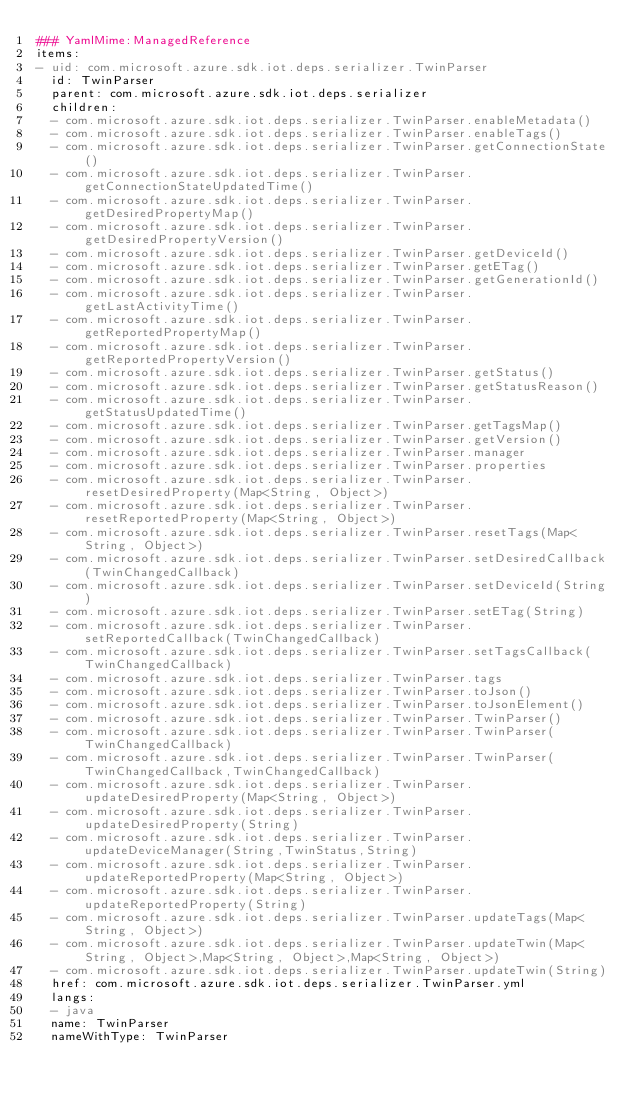<code> <loc_0><loc_0><loc_500><loc_500><_YAML_>### YamlMime:ManagedReference
items:
- uid: com.microsoft.azure.sdk.iot.deps.serializer.TwinParser
  id: TwinParser
  parent: com.microsoft.azure.sdk.iot.deps.serializer
  children:
  - com.microsoft.azure.sdk.iot.deps.serializer.TwinParser.enableMetadata()
  - com.microsoft.azure.sdk.iot.deps.serializer.TwinParser.enableTags()
  - com.microsoft.azure.sdk.iot.deps.serializer.TwinParser.getConnectionState()
  - com.microsoft.azure.sdk.iot.deps.serializer.TwinParser.getConnectionStateUpdatedTime()
  - com.microsoft.azure.sdk.iot.deps.serializer.TwinParser.getDesiredPropertyMap()
  - com.microsoft.azure.sdk.iot.deps.serializer.TwinParser.getDesiredPropertyVersion()
  - com.microsoft.azure.sdk.iot.deps.serializer.TwinParser.getDeviceId()
  - com.microsoft.azure.sdk.iot.deps.serializer.TwinParser.getETag()
  - com.microsoft.azure.sdk.iot.deps.serializer.TwinParser.getGenerationId()
  - com.microsoft.azure.sdk.iot.deps.serializer.TwinParser.getLastActivityTime()
  - com.microsoft.azure.sdk.iot.deps.serializer.TwinParser.getReportedPropertyMap()
  - com.microsoft.azure.sdk.iot.deps.serializer.TwinParser.getReportedPropertyVersion()
  - com.microsoft.azure.sdk.iot.deps.serializer.TwinParser.getStatus()
  - com.microsoft.azure.sdk.iot.deps.serializer.TwinParser.getStatusReason()
  - com.microsoft.azure.sdk.iot.deps.serializer.TwinParser.getStatusUpdatedTime()
  - com.microsoft.azure.sdk.iot.deps.serializer.TwinParser.getTagsMap()
  - com.microsoft.azure.sdk.iot.deps.serializer.TwinParser.getVersion()
  - com.microsoft.azure.sdk.iot.deps.serializer.TwinParser.manager
  - com.microsoft.azure.sdk.iot.deps.serializer.TwinParser.properties
  - com.microsoft.azure.sdk.iot.deps.serializer.TwinParser.resetDesiredProperty(Map<String, Object>)
  - com.microsoft.azure.sdk.iot.deps.serializer.TwinParser.resetReportedProperty(Map<String, Object>)
  - com.microsoft.azure.sdk.iot.deps.serializer.TwinParser.resetTags(Map<String, Object>)
  - com.microsoft.azure.sdk.iot.deps.serializer.TwinParser.setDesiredCallback(TwinChangedCallback)
  - com.microsoft.azure.sdk.iot.deps.serializer.TwinParser.setDeviceId(String)
  - com.microsoft.azure.sdk.iot.deps.serializer.TwinParser.setETag(String)
  - com.microsoft.azure.sdk.iot.deps.serializer.TwinParser.setReportedCallback(TwinChangedCallback)
  - com.microsoft.azure.sdk.iot.deps.serializer.TwinParser.setTagsCallback(TwinChangedCallback)
  - com.microsoft.azure.sdk.iot.deps.serializer.TwinParser.tags
  - com.microsoft.azure.sdk.iot.deps.serializer.TwinParser.toJson()
  - com.microsoft.azure.sdk.iot.deps.serializer.TwinParser.toJsonElement()
  - com.microsoft.azure.sdk.iot.deps.serializer.TwinParser.TwinParser()
  - com.microsoft.azure.sdk.iot.deps.serializer.TwinParser.TwinParser(TwinChangedCallback)
  - com.microsoft.azure.sdk.iot.deps.serializer.TwinParser.TwinParser(TwinChangedCallback,TwinChangedCallback)
  - com.microsoft.azure.sdk.iot.deps.serializer.TwinParser.updateDesiredProperty(Map<String, Object>)
  - com.microsoft.azure.sdk.iot.deps.serializer.TwinParser.updateDesiredProperty(String)
  - com.microsoft.azure.sdk.iot.deps.serializer.TwinParser.updateDeviceManager(String,TwinStatus,String)
  - com.microsoft.azure.sdk.iot.deps.serializer.TwinParser.updateReportedProperty(Map<String, Object>)
  - com.microsoft.azure.sdk.iot.deps.serializer.TwinParser.updateReportedProperty(String)
  - com.microsoft.azure.sdk.iot.deps.serializer.TwinParser.updateTags(Map<String, Object>)
  - com.microsoft.azure.sdk.iot.deps.serializer.TwinParser.updateTwin(Map<String, Object>,Map<String, Object>,Map<String, Object>)
  - com.microsoft.azure.sdk.iot.deps.serializer.TwinParser.updateTwin(String)
  href: com.microsoft.azure.sdk.iot.deps.serializer.TwinParser.yml
  langs:
  - java
  name: TwinParser
  nameWithType: TwinParser</code> 